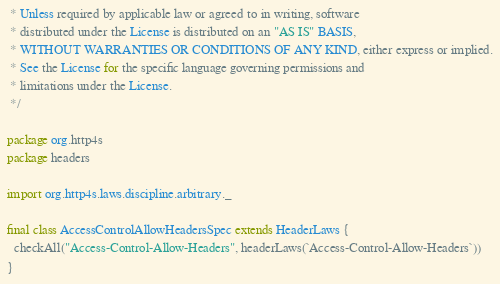<code> <loc_0><loc_0><loc_500><loc_500><_Scala_> * Unless required by applicable law or agreed to in writing, software
 * distributed under the License is distributed on an "AS IS" BASIS,
 * WITHOUT WARRANTIES OR CONDITIONS OF ANY KIND, either express or implied.
 * See the License for the specific language governing permissions and
 * limitations under the License.
 */

package org.http4s
package headers

import org.http4s.laws.discipline.arbitrary._

final class AccessControlAllowHeadersSpec extends HeaderLaws {
  checkAll("Access-Control-Allow-Headers", headerLaws(`Access-Control-Allow-Headers`))
}
</code> 